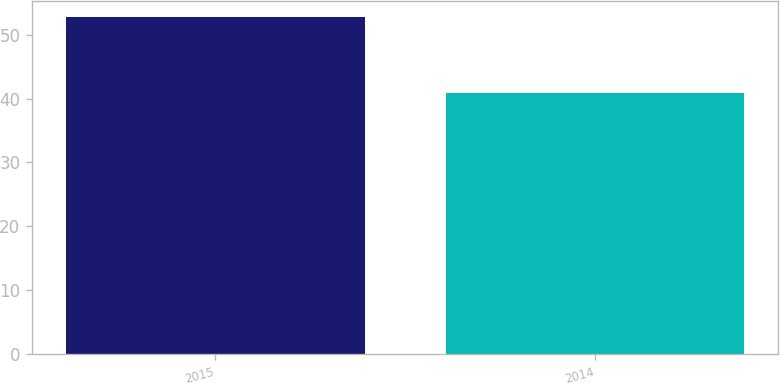<chart> <loc_0><loc_0><loc_500><loc_500><bar_chart><fcel>2015<fcel>2014<nl><fcel>52.73<fcel>40.93<nl></chart> 